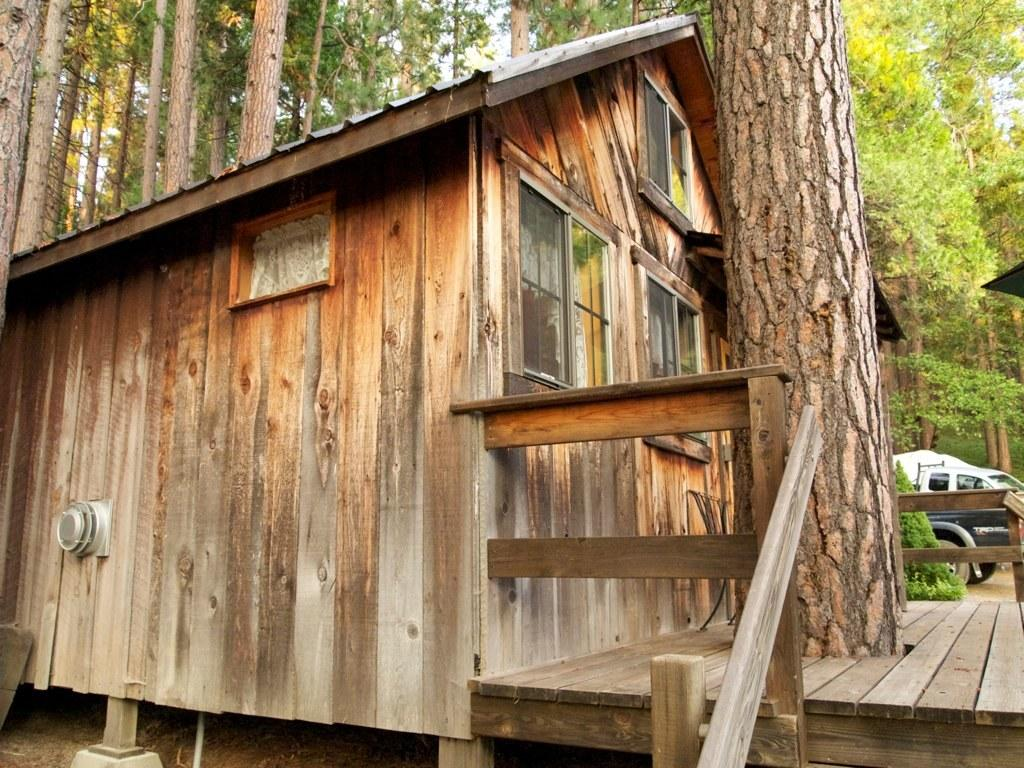What type of structure is in the image? There is a shack in the image. What can be seen on the right side of the image? There is a tree trunk on the right side of the image. What is visible in the background of the image? There are multiple trees and a vehicle visible in the background of the image. Where is the faucet located in the image? There is no faucet present in the image. What type of cow can be seen grazing near the shack in the image? There is no cow present in the image. 